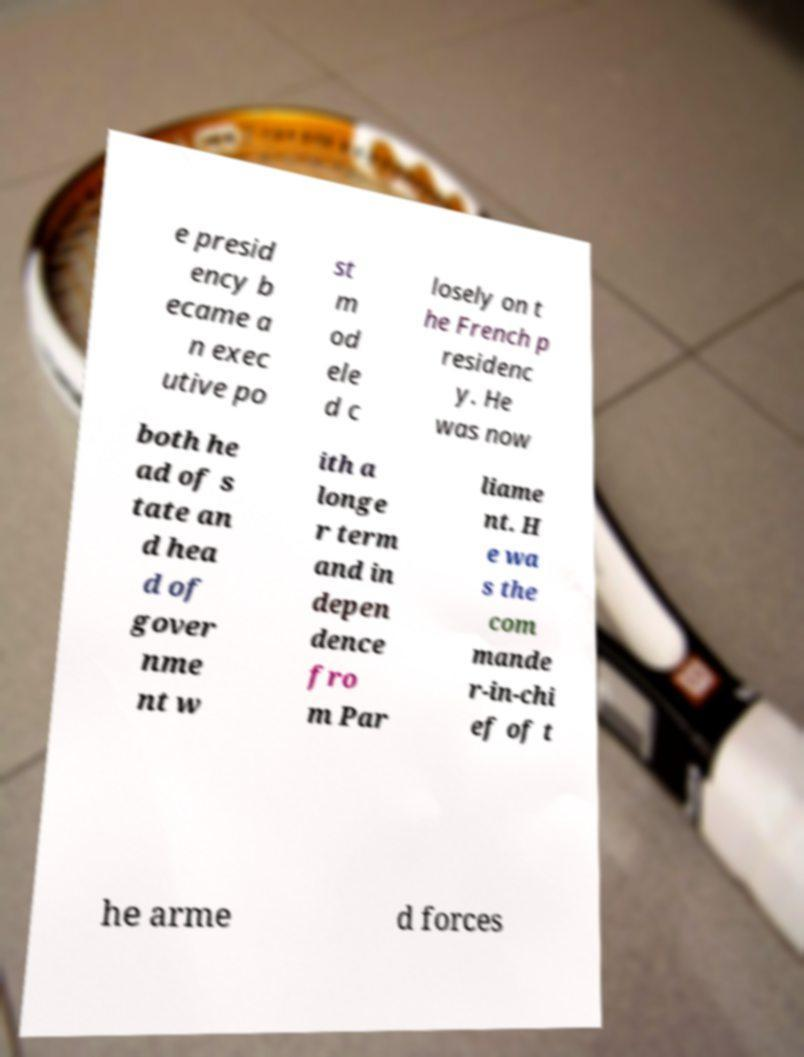There's text embedded in this image that I need extracted. Can you transcribe it verbatim? e presid ency b ecame a n exec utive po st m od ele d c losely on t he French p residenc y. He was now both he ad of s tate an d hea d of gover nme nt w ith a longe r term and in depen dence fro m Par liame nt. H e wa s the com mande r-in-chi ef of t he arme d forces 